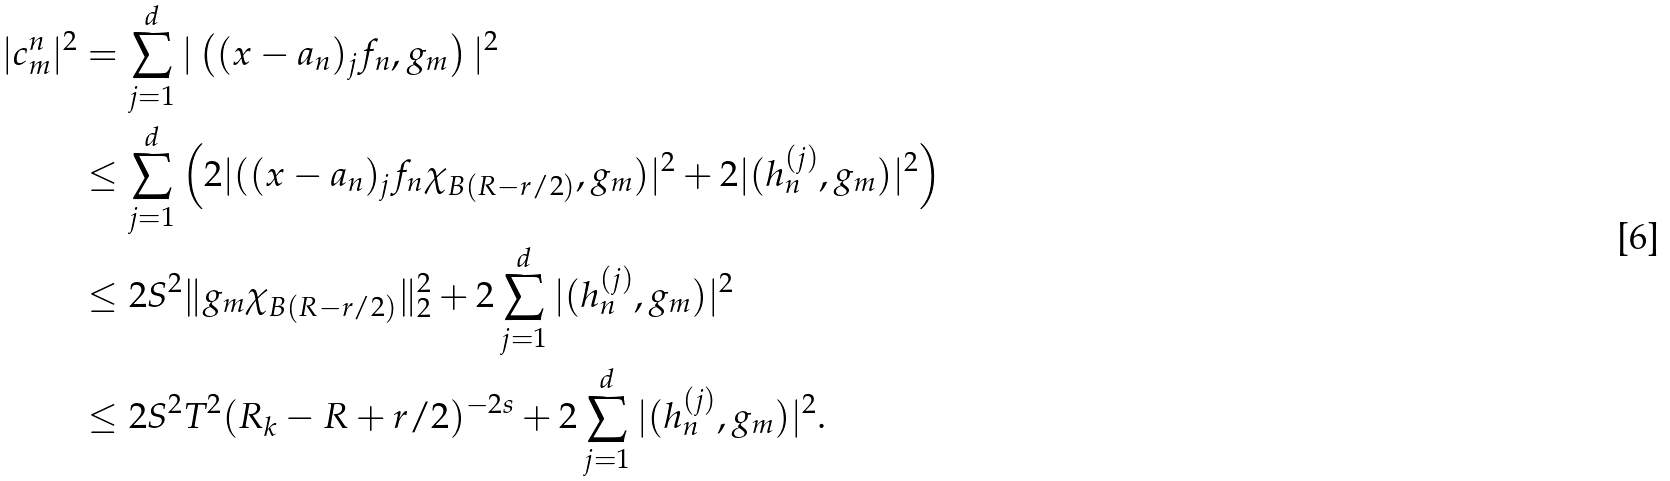<formula> <loc_0><loc_0><loc_500><loc_500>| c _ { m } ^ { n } | ^ { 2 } & = \sum _ { j = 1 } ^ { d } | \left ( ( x - a _ { n } ) _ { j } f _ { n } , g _ { m } \right ) | ^ { 2 } \\ & \leq \sum _ { j = 1 } ^ { d } \left ( 2 | ( ( x - a _ { n } ) _ { j } f _ { n } \chi _ { B ( R - r / 2 ) } , g _ { m } ) | ^ { 2 } + 2 | ( h _ { n } ^ { ( j ) } , g _ { m } ) | ^ { 2 } \right ) \\ & \leq 2 S ^ { 2 } \| g _ { m } \chi _ { B ( R - r / 2 ) } \| _ { 2 } ^ { 2 } + 2 \sum _ { j = 1 } ^ { d } | ( h _ { n } ^ { ( j ) } , g _ { m } ) | ^ { 2 } \\ & \leq 2 S ^ { 2 } T ^ { 2 } ( R _ { k } - R + r / 2 ) ^ { - 2 s } + 2 \sum _ { j = 1 } ^ { d } | ( h _ { n } ^ { ( j ) } , g _ { m } ) | ^ { 2 } .</formula> 